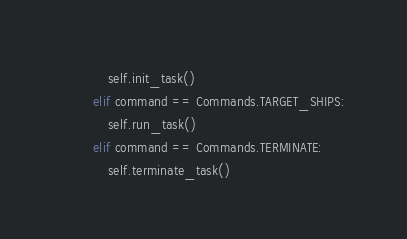Convert code to text. <code><loc_0><loc_0><loc_500><loc_500><_Python_>            self.init_task()
        elif command == Commands.TARGET_SHIPS:
            self.run_task()
        elif command == Commands.TERMINATE:
            self.terminate_task()</code> 